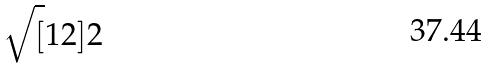Convert formula to latex. <formula><loc_0><loc_0><loc_500><loc_500>\sqrt { [ } 1 2 ] { 2 }</formula> 